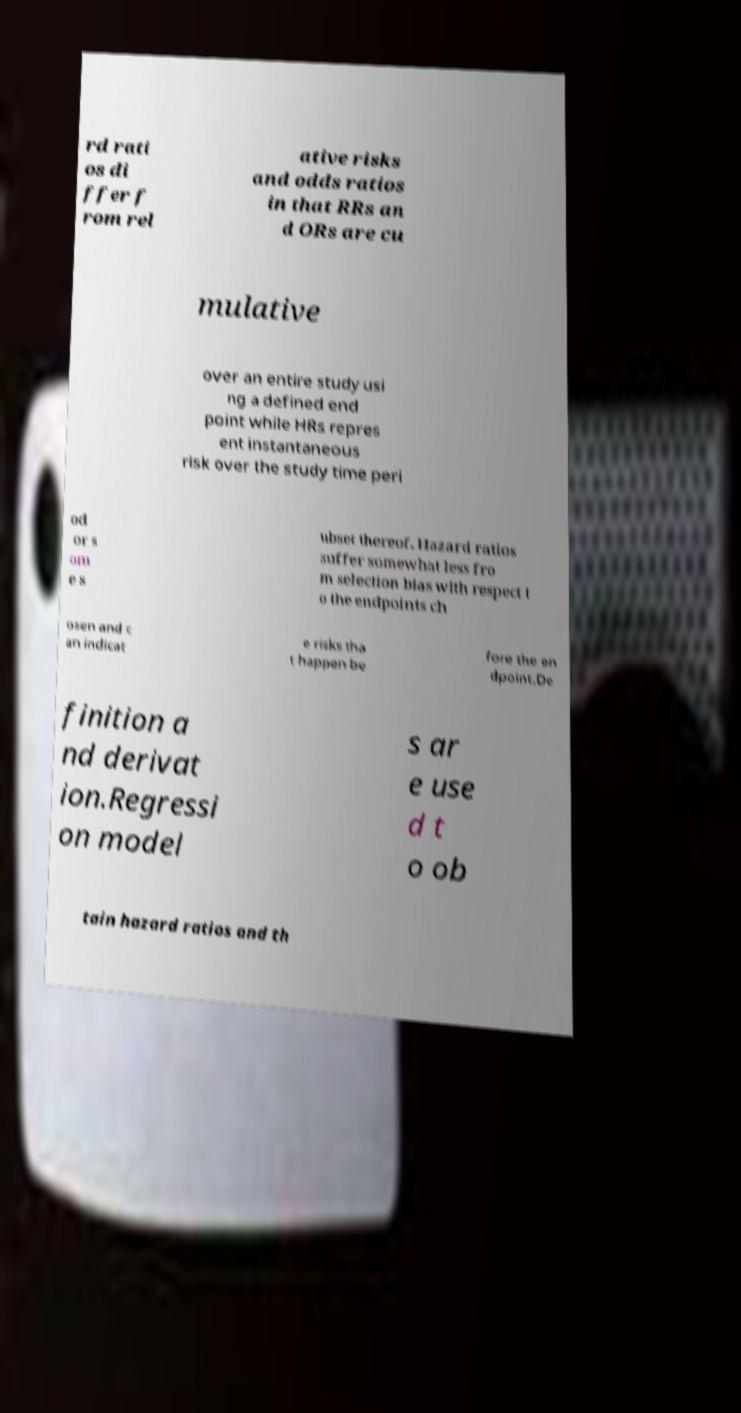Could you extract and type out the text from this image? rd rati os di ffer f rom rel ative risks and odds ratios in that RRs an d ORs are cu mulative over an entire study usi ng a defined end point while HRs repres ent instantaneous risk over the study time peri od or s om e s ubset thereof. Hazard ratios suffer somewhat less fro m selection bias with respect t o the endpoints ch osen and c an indicat e risks tha t happen be fore the en dpoint.De finition a nd derivat ion.Regressi on model s ar e use d t o ob tain hazard ratios and th 